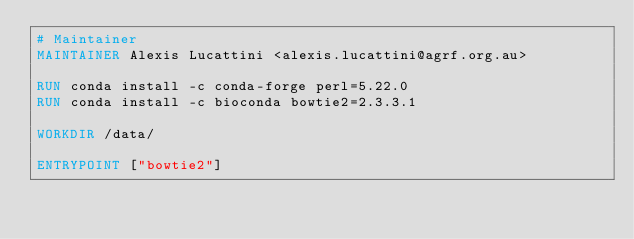Convert code to text. <code><loc_0><loc_0><loc_500><loc_500><_Dockerfile_># Maintainer
MAINTAINER Alexis Lucattini <alexis.lucattini@agrf.org.au>

RUN conda install -c conda-forge perl=5.22.0
RUN conda install -c bioconda bowtie2=2.3.3.1

WORKDIR /data/

ENTRYPOINT ["bowtie2"]
</code> 